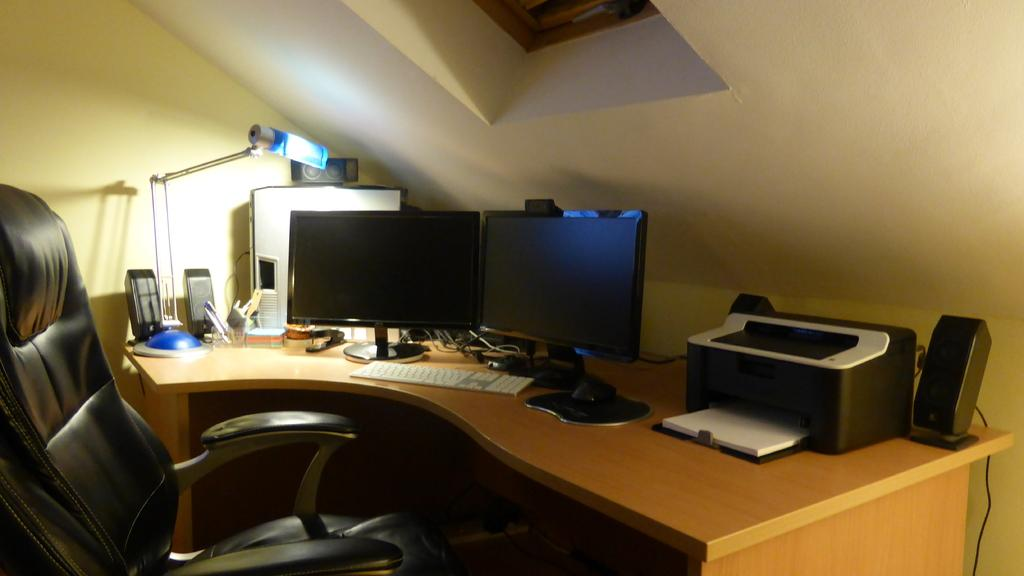What type of furniture is present in the room? There is a chair in the room. Can you describe the chair? The chair is black. What other objects can be found in the room? There is a table in the room. What items are on the table? There are speakers, a CPU, a lamp, monitors, a printer, a mouse, and a keyboard on the table. What type of oven is present in the room? There is no oven present in the room; the image only shows a black chair, a table, and various electronic devices on the table. 